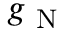<formula> <loc_0><loc_0><loc_500><loc_500>g _ { N }</formula> 